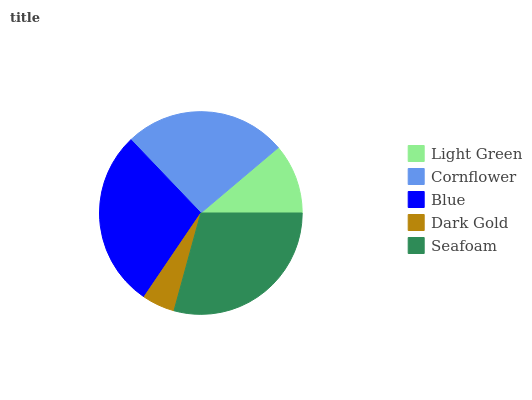Is Dark Gold the minimum?
Answer yes or no. Yes. Is Seafoam the maximum?
Answer yes or no. Yes. Is Cornflower the minimum?
Answer yes or no. No. Is Cornflower the maximum?
Answer yes or no. No. Is Cornflower greater than Light Green?
Answer yes or no. Yes. Is Light Green less than Cornflower?
Answer yes or no. Yes. Is Light Green greater than Cornflower?
Answer yes or no. No. Is Cornflower less than Light Green?
Answer yes or no. No. Is Cornflower the high median?
Answer yes or no. Yes. Is Cornflower the low median?
Answer yes or no. Yes. Is Light Green the high median?
Answer yes or no. No. Is Light Green the low median?
Answer yes or no. No. 